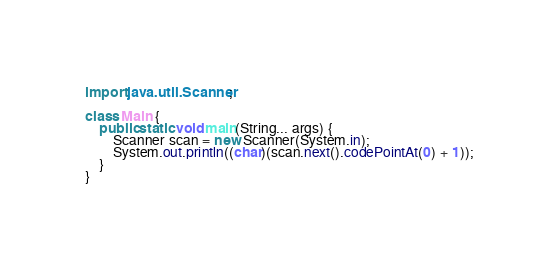<code> <loc_0><loc_0><loc_500><loc_500><_Java_>import java.util.Scanner;

class Main {
	public static void main(String... args) {
		Scanner scan = new Scanner(System.in);
		System.out.println((char)(scan.next().codePointAt(0) + 1));
	}
}
</code> 